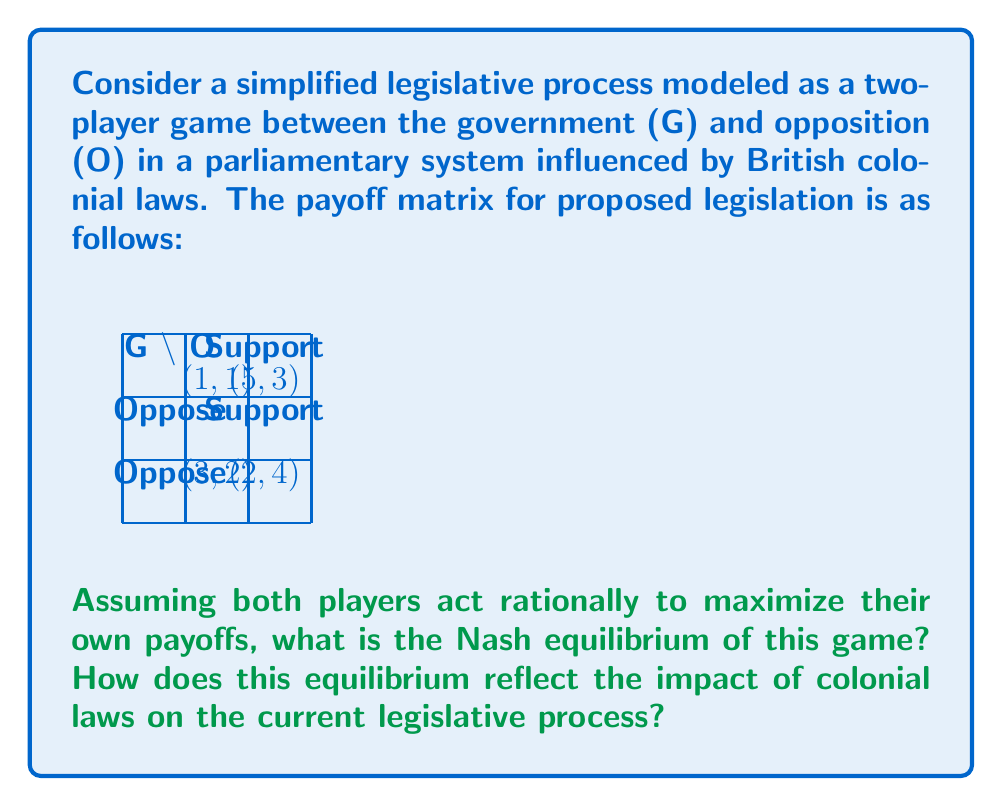Help me with this question. To solve this problem, we need to follow these steps:

1. Identify the dominant strategies for each player:

   For the Government (G):
   - If O supports: 5 > 1, so G prefers to support
   - If O opposes: 3 > 2, so G prefers to oppose
   G has no dominant strategy

   For the Opposition (O):
   - If G supports: 3 < 4, so O prefers to oppose
   - If G opposes: 2 > 1, so O prefers to oppose
   O's dominant strategy is to oppose

2. Find the Nash equilibrium:
   Given O's dominant strategy to oppose, G's best response is to oppose (payoff 3 vs 2).
   The Nash equilibrium is (Oppose, Oppose) with payoffs (3, 2).

3. Interpret the result:
   The Nash equilibrium (Oppose, Oppose) reflects a confrontational legislative process, which can be attributed to the adversarial nature of the Westminster system inherited from British colonial rule. This system often leads to a strong government-opposition divide, where the opposition's role is to scrutinize and challenge the government's proposals.

4. Quantify the impact:
   We can quantify the impact of colonial laws by comparing the equilibrium payoff (3, 2) to the potential cooperative outcome (5, 3). The colonial legacy results in a loss of 2 utility points for the government and 1 for the opposition, totaling a societal loss of 3 points (or 37.5% of the maximum possible total utility).

This game-theoretic model demonstrates how the parliamentary structure, shaped by colonial laws, can lead to suboptimal outcomes in the legislative process, prioritizing political opposition over cooperative law-making.
Answer: Nash equilibrium: (Oppose, Oppose) with payoffs (3, 2). Impact: 37.5% loss in total utility compared to optimal cooperation. 